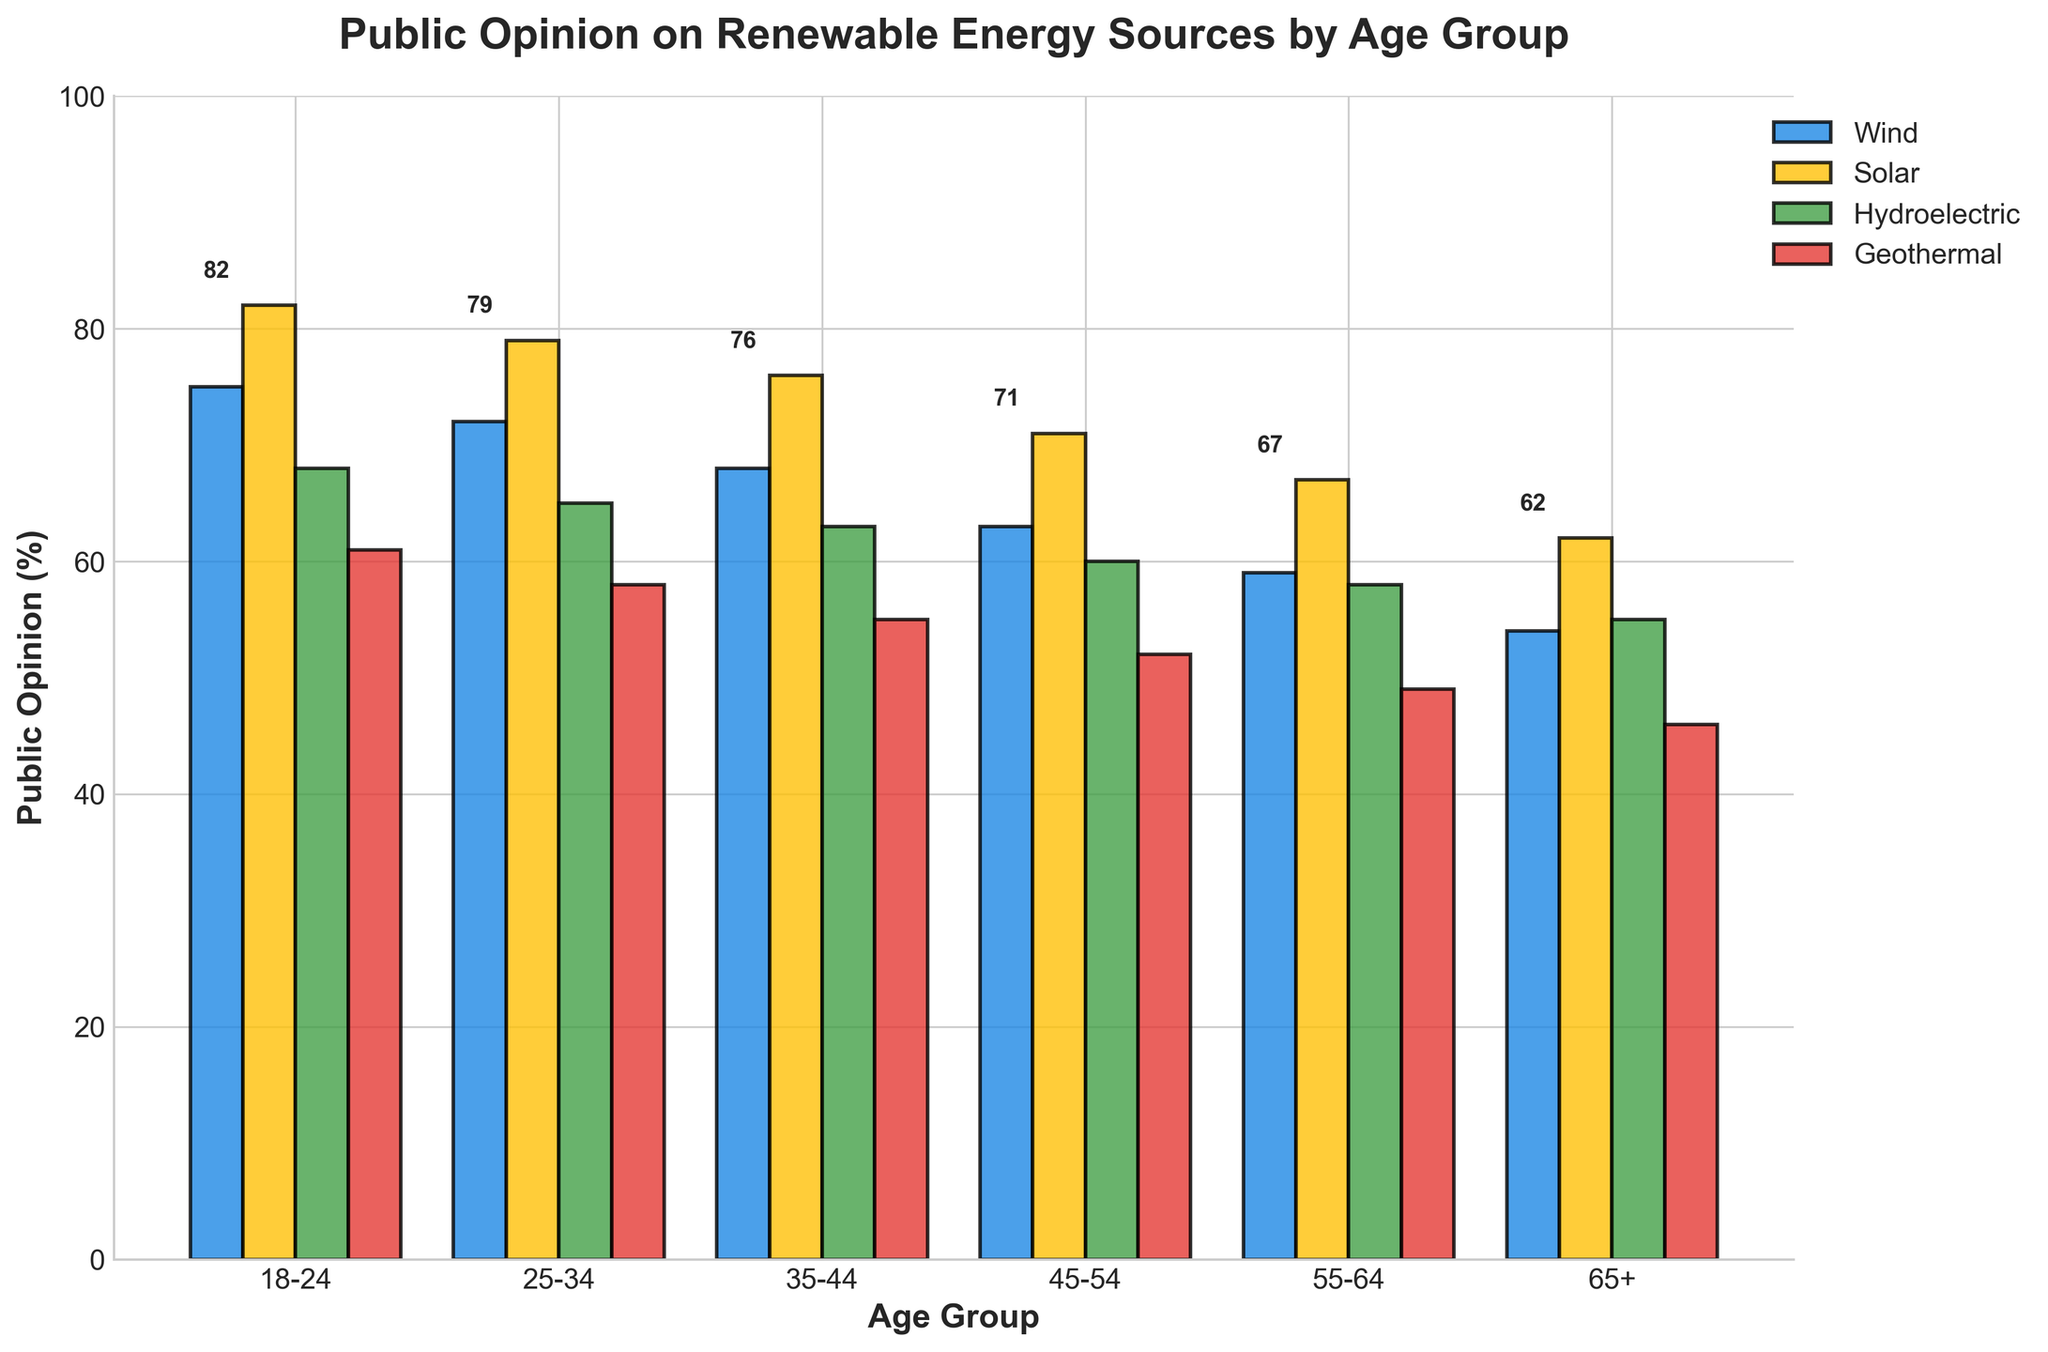What's the highest public opinion percentage for Solar energy? Look at the Solar bars and identify the highest value. The value is 82 in the 18-24 age group.
Answer: 82 Which age group shows the least support for Wind energy? Identify the shortest bar for Wind. The shortest Wind bar is for the 65+ age group, with a value of 54.
Answer: 65+ Which renewable energy source receives the highest overall support across all age groups? Compare the heights of the bars for each energy source across all age groups. Solar generally has the highest bars.
Answer: Solar What is the difference in public opinion for Geothermal energy between the 18-24 and 65+ age groups? Subtract the 65+ group's value for Geothermal (46) from the 18-24 group's value (61). The difference is 61 - 46 = 15.
Answer: 15 How does support for Hydroelectric energy change from the 18-24 age group to the 55-64 age group? Note the reported values for Hydroelectric in both age groups, 68 for 18-24 and 58 for 55-64. The change is 68 - 58 = 10.
Answer: Decrease by 10 Which age group has the most significant difference between their opinions of Wind and Solar energy? Calculate the difference between Wind and Solar for each age group. The largest difference is in the 18-24 age group at 82 - 75 = 7.
Answer: 18-24 How does the public opinion of Solar energy in the 35-44 age group compare to Geothermal in the same age group? Compare the Solar (76) and Geothermal (55) values for the 35-44 age group. 76 is higher than 55.
Answer: Solar has higher support What is the average public opinion for Hydroelectric energy across all age groups? Sum the Hydroelectric values (68, 65, 63, 60, 58, 55) and divide by the number of age groups (6). The average is (68 + 65 + 63 + 60 + 58 + 55) / 6 = 61.5.
Answer: 61.5 Which two renewable energy sources have the closest levels of public opinion in the 45-54 age group? Compare the values for all sources in the 45-54 age group. Wind (63) and Hydroelectric (60) are the closest. The difference is 3.
Answer: Wind and Hydroelectric In which age group is the opinion about Geothermal energy the lowest, and what is the value? Identify the shortest bar for Geothermal. The shortest is the 65+ age group at 46.
Answer: 65+, 46 